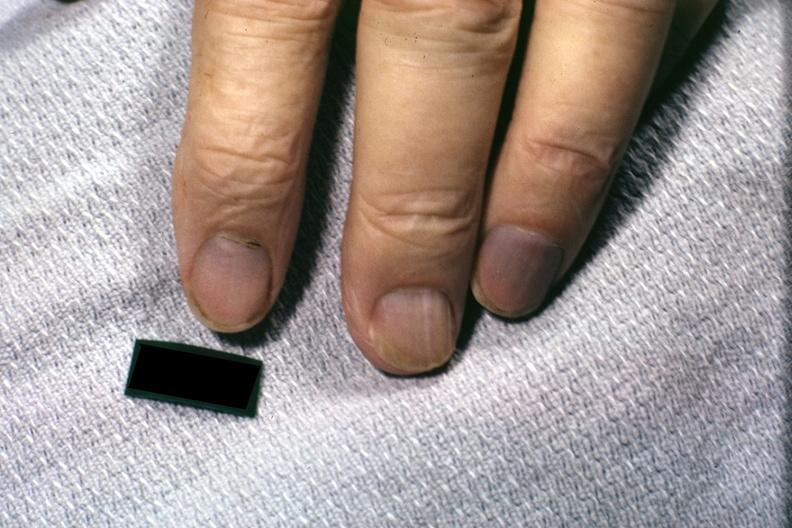re extremities present?
Answer the question using a single word or phrase. Yes 